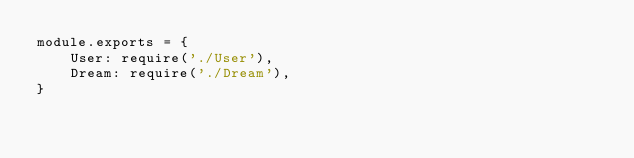<code> <loc_0><loc_0><loc_500><loc_500><_JavaScript_>module.exports = {
    User: require('./User'),
    Dream: require('./Dream'),
}</code> 